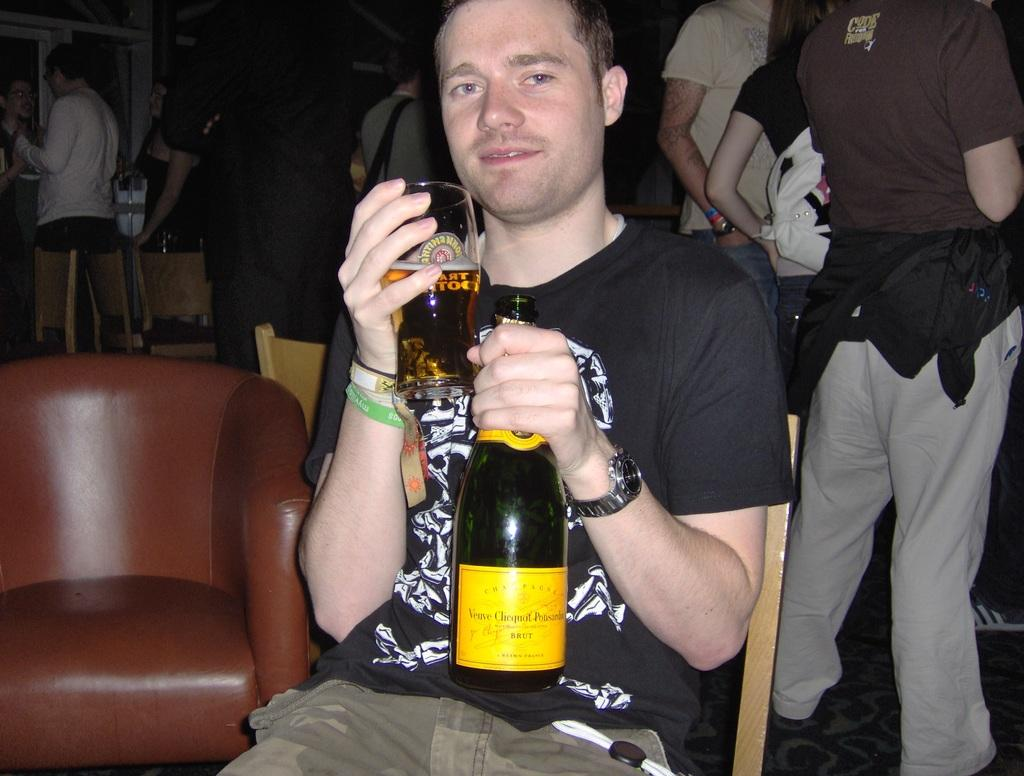What can be seen in the background of the image? There are persons standing in the background. What is the man wearing in the image? The man is wearing a black t-shirt. What is the man holding in his hand? The man is holding a glass and a bottle in his hand. What accessory is the man wearing? The man is wearing a watch. What type of furniture is present in the image? There is a chair in the image. Where is the stove located in the image? There is no stove present in the image. What type of stitch is the man using to hold the glass and bottle? The man is not using a stitch to hold the glass and bottle; he is simply holding them in his hand. 